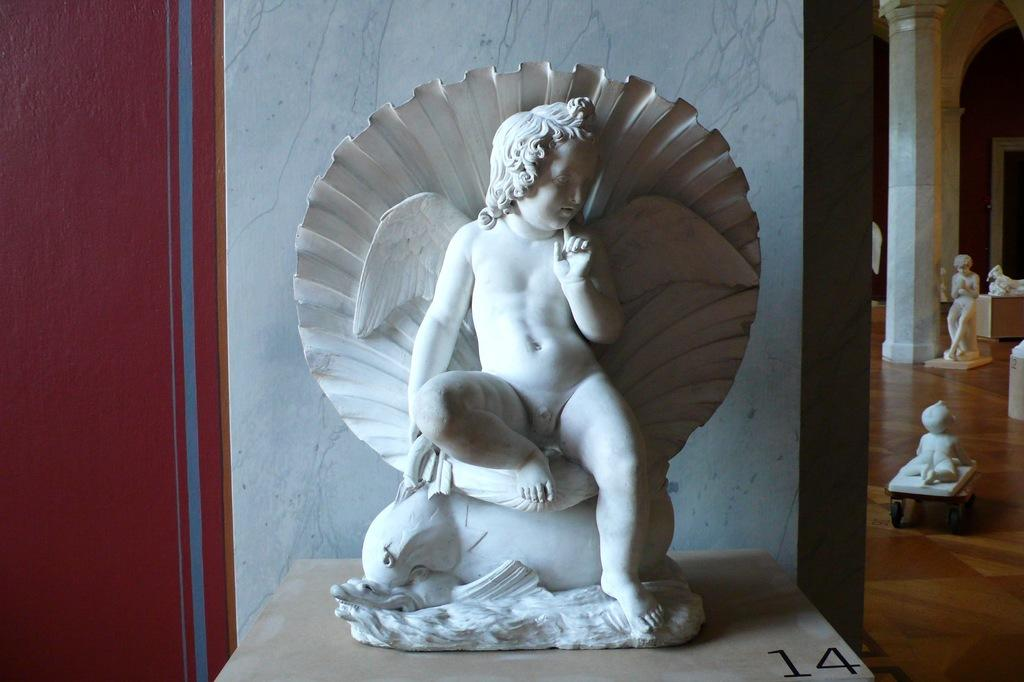What is located on the floor in the image? There are statues on the floor. Where is another statue located in the image? There is a statue on a table near the wall. What architectural features can be seen in the image? There are pillars in the image. What color is one of the objects in the image? There is a red color object in the image. What type of tax can be seen being paid by the statues in the image? There is no indication of tax or any financial transaction in the image; it features statues in various locations. What letters are visible on the statues in the image? There are no letters or text visible on the statues in the image. 